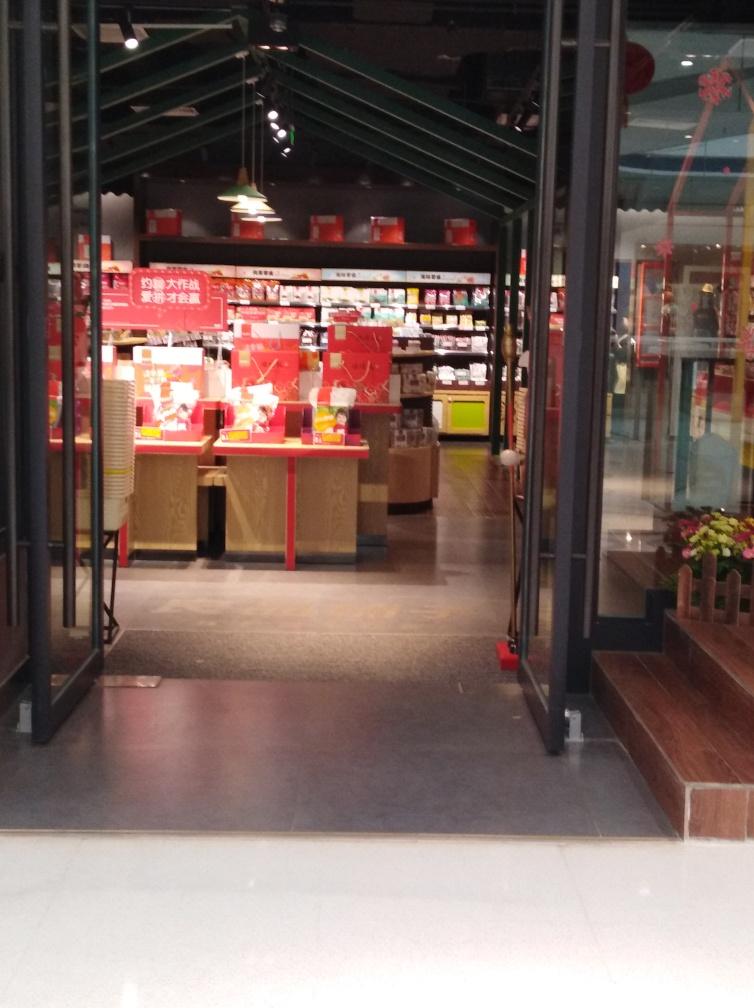Describe the lighting in the image. The lighting in the image seems to be a combination of natural and artificial sources. There is a soft glow coming from within the store, indicating overhead artificial lighting which is common in retail spaces. The ambiance created is welcoming and enhances the visibility of the products on sale. There's also a notable shadow cast across the floor, suggesting that there may be stronger lights outside the frame of the image, or perhaps it is an effect of the natural light entering from outside. Can you tell if this photo was taken during the day or at night? It's challenging to determine the exact time of day definitively, as the storefront is primarily illuminated by interior lighting and the view outside the shop is limited. However, there appears to be some natural light reflecting off the floor outside the shop, which might indicate that the photo was taken during the day or early evening when there is still some ambient daylight present. 